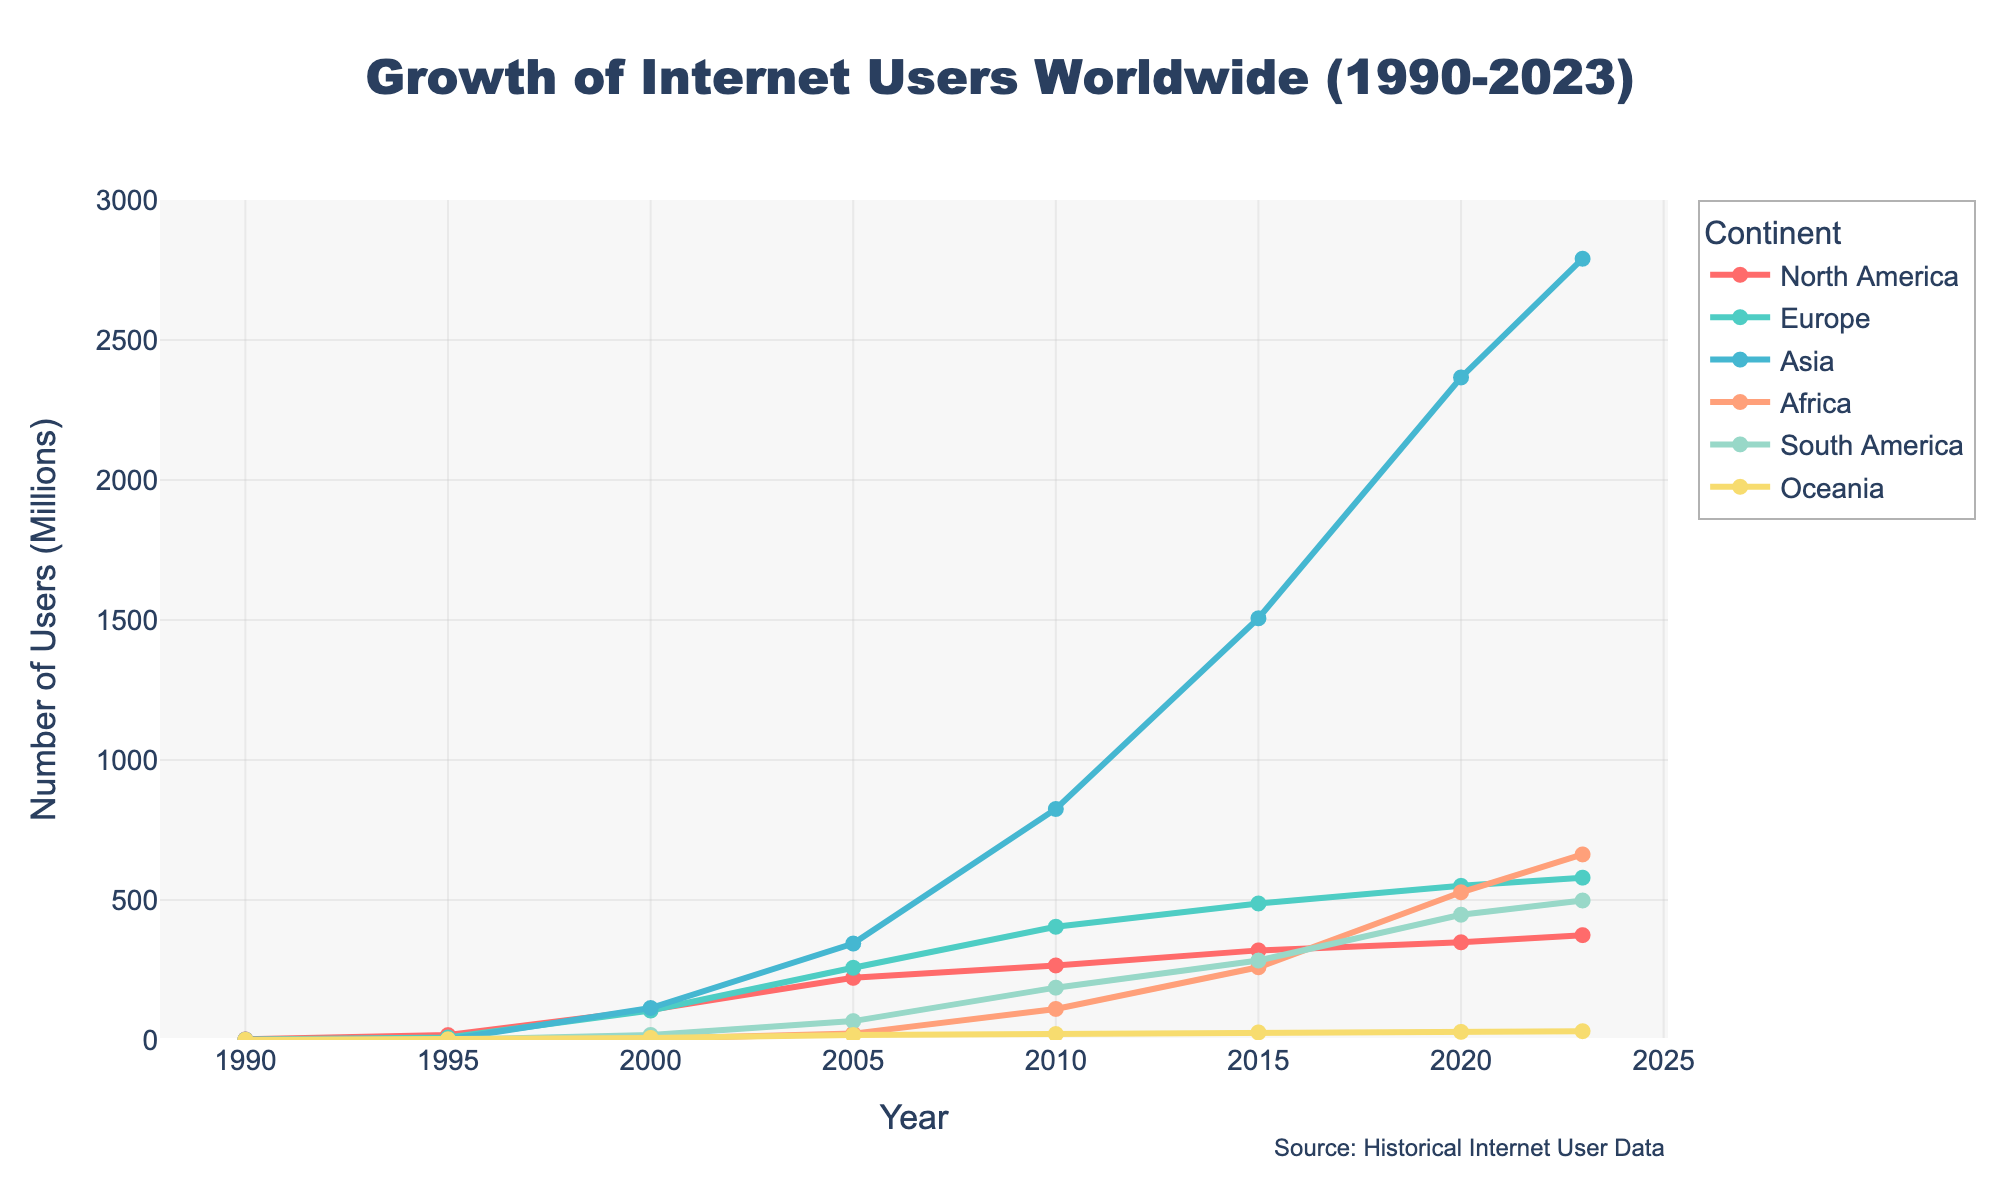What was the growth in internet users in Europe from 1995 to 2023? To find the growth, subtract the number of users in 1995 from the number of users in 2023. For Europe: 579.8 (2023) - 8.9 (1995). The difference is 570.9 million users.
Answer: 570.9 million Which continent had the highest number of internet users in 2023? Observing the figure, Asia had the highest number of internet users in 2023 at 2790.3 million.
Answer: Asia How did the number of internet users in Africa change between 2000 and 2020? Subtract the number of users in 2000 from the number of users in 2020 for Africa: 527.6 (2020) - 4.5 (2000) = 523.1 million users.
Answer: 523.1 million Which continent showed a more rapid increase in users, South America or Oceania, between 1990 and 2015? To determine this, calculate the increase for each continent over the period and compare them. For South America: 283.8 (2015) - 0.1 (1990) = 283.7 million users. For Oceania: 27.1 (2015) - 0.4 (1990) = 26.7 million users. South America showed a more rapid increase.
Answer: South America What is the average number of internet users in North America from 2010 to 2023? Add the number of users for 2010, 2015, 2020, and 2023, then divide by 4: (266.2 + 320.1 + 348.9 + 374.5) / 4 = 327.43 million users.
Answer: 327.43 million By how much did the number of internet users in Asia surpass the number of users in Europe in the year 2020? Subtract the number of users in Europe from the number of users in Asia for 2020: 2366.2 (Asia) - 550.6 (Europe) = 1815.6 million users.
Answer: 1815.6 million What is the trend of internet user growth in Oceania from 1990 to 2023? Observing the graph, there's a consistent increase with no decline. From 0.4 million in 1990 to 31.4 million in 2023.
Answer: Consistently increasing Which continent had the least number of internet users in 1990, and how many users did it have? Observing the figure, Africa had the least number of internet users in 1990, with 0.02 million users.
Answer: Africa, 0.02 million Compare the user growth rates of Europe and North America between 2005 and 2015. Which continent experienced higher growth, and by how much? For Europe: 487.6 (2015) - 257.9 (2005) = 229.7 million users. For North America: 320.1 (2015) - 221.9 (2005) = 98.2 million users. Europe experienced higher growth by 229.7 - 98.2 = 131.5 million users.
Answer: Europe, 131.5 million What is the difference in internet users between South America and Oceania in 2023? Subtract the number of users in Oceania from the number of users in South America: 498.2 (South America) - 31.4 (Oceania) = 466.8 million users.
Answer: 466.8 million 